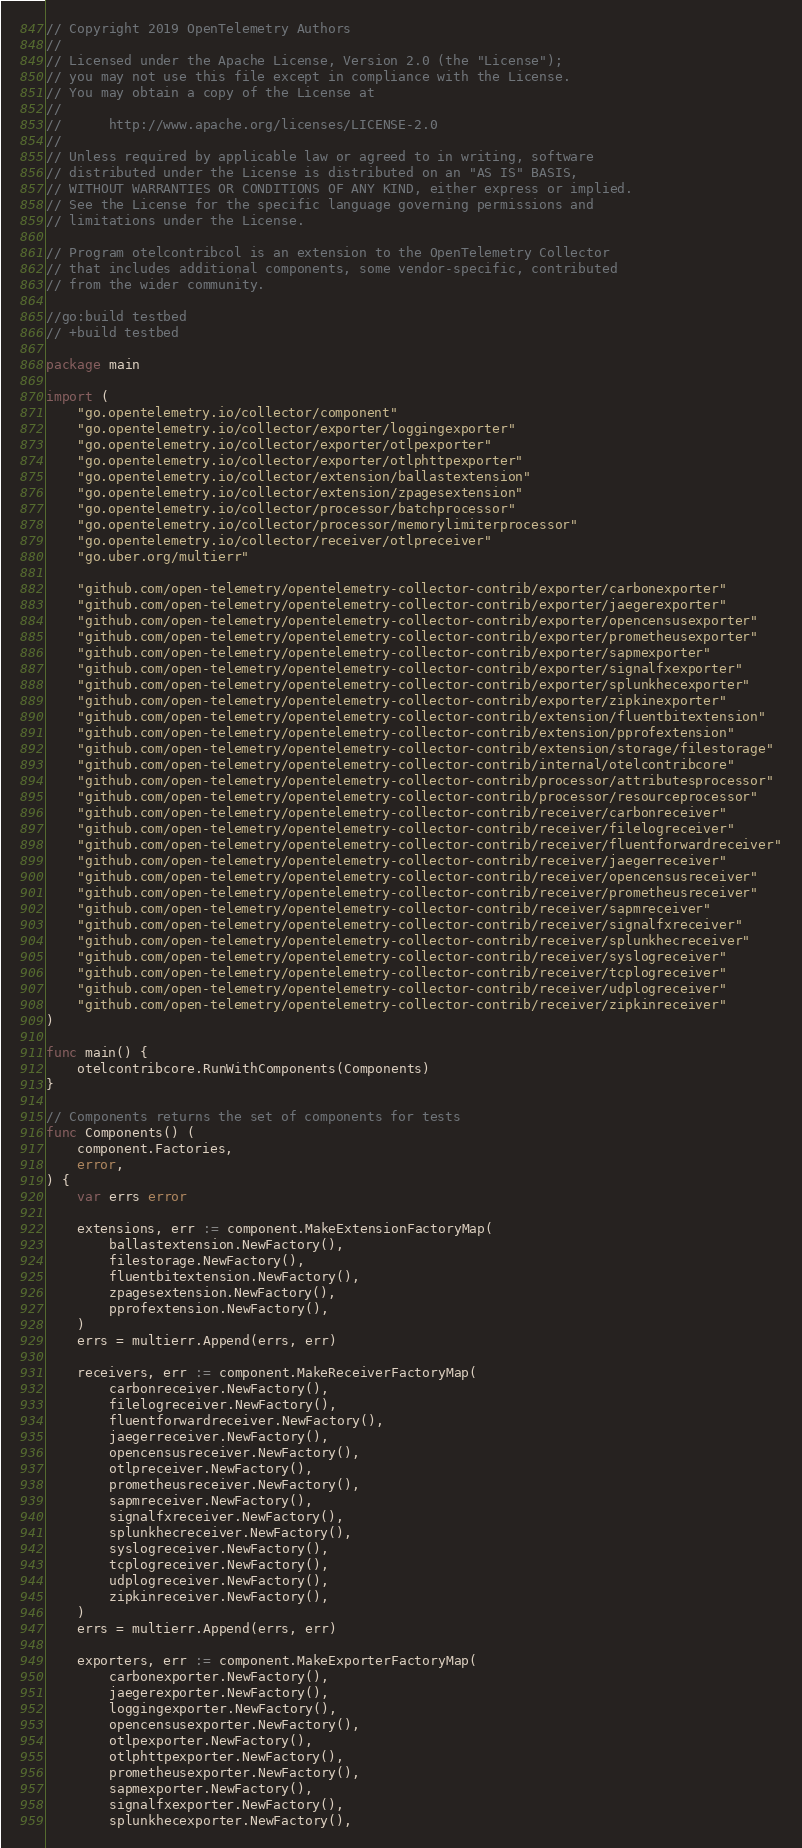<code> <loc_0><loc_0><loc_500><loc_500><_Go_>// Copyright 2019 OpenTelemetry Authors
//
// Licensed under the Apache License, Version 2.0 (the "License");
// you may not use this file except in compliance with the License.
// You may obtain a copy of the License at
//
//      http://www.apache.org/licenses/LICENSE-2.0
//
// Unless required by applicable law or agreed to in writing, software
// distributed under the License is distributed on an "AS IS" BASIS,
// WITHOUT WARRANTIES OR CONDITIONS OF ANY KIND, either express or implied.
// See the License for the specific language governing permissions and
// limitations under the License.

// Program otelcontribcol is an extension to the OpenTelemetry Collector
// that includes additional components, some vendor-specific, contributed
// from the wider community.

//go:build testbed
// +build testbed

package main

import (
	"go.opentelemetry.io/collector/component"
	"go.opentelemetry.io/collector/exporter/loggingexporter"
	"go.opentelemetry.io/collector/exporter/otlpexporter"
	"go.opentelemetry.io/collector/exporter/otlphttpexporter"
	"go.opentelemetry.io/collector/extension/ballastextension"
	"go.opentelemetry.io/collector/extension/zpagesextension"
	"go.opentelemetry.io/collector/processor/batchprocessor"
	"go.opentelemetry.io/collector/processor/memorylimiterprocessor"
	"go.opentelemetry.io/collector/receiver/otlpreceiver"
	"go.uber.org/multierr"

	"github.com/open-telemetry/opentelemetry-collector-contrib/exporter/carbonexporter"
	"github.com/open-telemetry/opentelemetry-collector-contrib/exporter/jaegerexporter"
	"github.com/open-telemetry/opentelemetry-collector-contrib/exporter/opencensusexporter"
	"github.com/open-telemetry/opentelemetry-collector-contrib/exporter/prometheusexporter"
	"github.com/open-telemetry/opentelemetry-collector-contrib/exporter/sapmexporter"
	"github.com/open-telemetry/opentelemetry-collector-contrib/exporter/signalfxexporter"
	"github.com/open-telemetry/opentelemetry-collector-contrib/exporter/splunkhecexporter"
	"github.com/open-telemetry/opentelemetry-collector-contrib/exporter/zipkinexporter"
	"github.com/open-telemetry/opentelemetry-collector-contrib/extension/fluentbitextension"
	"github.com/open-telemetry/opentelemetry-collector-contrib/extension/pprofextension"
	"github.com/open-telemetry/opentelemetry-collector-contrib/extension/storage/filestorage"
	"github.com/open-telemetry/opentelemetry-collector-contrib/internal/otelcontribcore"
	"github.com/open-telemetry/opentelemetry-collector-contrib/processor/attributesprocessor"
	"github.com/open-telemetry/opentelemetry-collector-contrib/processor/resourceprocessor"
	"github.com/open-telemetry/opentelemetry-collector-contrib/receiver/carbonreceiver"
	"github.com/open-telemetry/opentelemetry-collector-contrib/receiver/filelogreceiver"
	"github.com/open-telemetry/opentelemetry-collector-contrib/receiver/fluentforwardreceiver"
	"github.com/open-telemetry/opentelemetry-collector-contrib/receiver/jaegerreceiver"
	"github.com/open-telemetry/opentelemetry-collector-contrib/receiver/opencensusreceiver"
	"github.com/open-telemetry/opentelemetry-collector-contrib/receiver/prometheusreceiver"
	"github.com/open-telemetry/opentelemetry-collector-contrib/receiver/sapmreceiver"
	"github.com/open-telemetry/opentelemetry-collector-contrib/receiver/signalfxreceiver"
	"github.com/open-telemetry/opentelemetry-collector-contrib/receiver/splunkhecreceiver"
	"github.com/open-telemetry/opentelemetry-collector-contrib/receiver/syslogreceiver"
	"github.com/open-telemetry/opentelemetry-collector-contrib/receiver/tcplogreceiver"
	"github.com/open-telemetry/opentelemetry-collector-contrib/receiver/udplogreceiver"
	"github.com/open-telemetry/opentelemetry-collector-contrib/receiver/zipkinreceiver"
)

func main() {
	otelcontribcore.RunWithComponents(Components)
}

// Components returns the set of components for tests
func Components() (
	component.Factories,
	error,
) {
	var errs error

	extensions, err := component.MakeExtensionFactoryMap(
		ballastextension.NewFactory(),
		filestorage.NewFactory(),
		fluentbitextension.NewFactory(),
		zpagesextension.NewFactory(),
		pprofextension.NewFactory(),
	)
	errs = multierr.Append(errs, err)

	receivers, err := component.MakeReceiverFactoryMap(
		carbonreceiver.NewFactory(),
		filelogreceiver.NewFactory(),
		fluentforwardreceiver.NewFactory(),
		jaegerreceiver.NewFactory(),
		opencensusreceiver.NewFactory(),
		otlpreceiver.NewFactory(),
		prometheusreceiver.NewFactory(),
		sapmreceiver.NewFactory(),
		signalfxreceiver.NewFactory(),
		splunkhecreceiver.NewFactory(),
		syslogreceiver.NewFactory(),
		tcplogreceiver.NewFactory(),
		udplogreceiver.NewFactory(),
		zipkinreceiver.NewFactory(),
	)
	errs = multierr.Append(errs, err)

	exporters, err := component.MakeExporterFactoryMap(
		carbonexporter.NewFactory(),
		jaegerexporter.NewFactory(),
		loggingexporter.NewFactory(),
		opencensusexporter.NewFactory(),
		otlpexporter.NewFactory(),
		otlphttpexporter.NewFactory(),
		prometheusexporter.NewFactory(),
		sapmexporter.NewFactory(),
		signalfxexporter.NewFactory(),
		splunkhecexporter.NewFactory(),</code> 